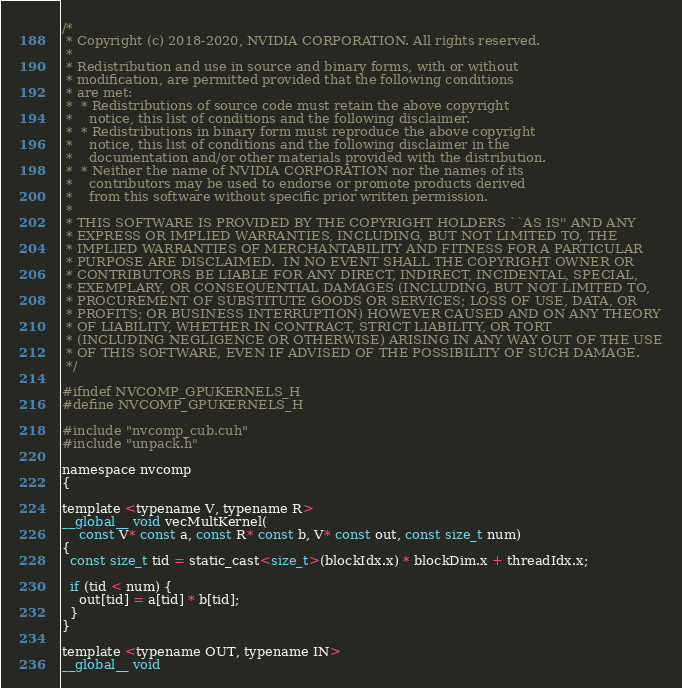<code> <loc_0><loc_0><loc_500><loc_500><_Cuda_>/*
 * Copyright (c) 2018-2020, NVIDIA CORPORATION. All rights reserved.
 *
 * Redistribution and use in source and binary forms, with or without
 * modification, are permitted provided that the following conditions
 * are met:
 *  * Redistributions of source code must retain the above copyright
 *    notice, this list of conditions and the following disclaimer.
 *  * Redistributions in binary form must reproduce the above copyright
 *    notice, this list of conditions and the following disclaimer in the
 *    documentation and/or other materials provided with the distribution.
 *  * Neither the name of NVIDIA CORPORATION nor the names of its
 *    contributors may be used to endorse or promote products derived
 *    from this software without specific prior written permission.
 *
 * THIS SOFTWARE IS PROVIDED BY THE COPYRIGHT HOLDERS ``AS IS'' AND ANY
 * EXPRESS OR IMPLIED WARRANTIES, INCLUDING, BUT NOT LIMITED TO, THE
 * IMPLIED WARRANTIES OF MERCHANTABILITY AND FITNESS FOR A PARTICULAR
 * PURPOSE ARE DISCLAIMED.  IN NO EVENT SHALL THE COPYRIGHT OWNER OR
 * CONTRIBUTORS BE LIABLE FOR ANY DIRECT, INDIRECT, INCIDENTAL, SPECIAL,
 * EXEMPLARY, OR CONSEQUENTIAL DAMAGES (INCLUDING, BUT NOT LIMITED TO,
 * PROCUREMENT OF SUBSTITUTE GOODS OR SERVICES; LOSS OF USE, DATA, OR
 * PROFITS; OR BUSINESS INTERRUPTION) HOWEVER CAUSED AND ON ANY THEORY
 * OF LIABILITY, WHETHER IN CONTRACT, STRICT LIABILITY, OR TORT
 * (INCLUDING NEGLIGENCE OR OTHERWISE) ARISING IN ANY WAY OUT OF THE USE
 * OF THIS SOFTWARE, EVEN IF ADVISED OF THE POSSIBILITY OF SUCH DAMAGE.
 */

#ifndef NVCOMP_GPUKERNELS_H
#define NVCOMP_GPUKERNELS_H

#include "nvcomp_cub.cuh"
#include "unpack.h"

namespace nvcomp
{

template <typename V, typename R>
__global__ void vecMultKernel(
    const V* const a, const R* const b, V* const out, const size_t num)
{
  const size_t tid = static_cast<size_t>(blockIdx.x) * blockDim.x + threadIdx.x;

  if (tid < num) {
    out[tid] = a[tid] * b[tid];
  }
}

template <typename OUT, typename IN>
__global__ void</code> 